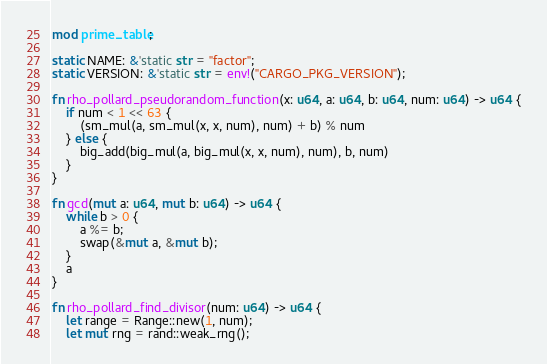<code> <loc_0><loc_0><loc_500><loc_500><_Rust_>mod prime_table;

static NAME: &'static str = "factor";
static VERSION: &'static str = env!("CARGO_PKG_VERSION");

fn rho_pollard_pseudorandom_function(x: u64, a: u64, b: u64, num: u64) -> u64 {
    if num < 1 << 63 {
        (sm_mul(a, sm_mul(x, x, num), num) + b) % num
    } else {
        big_add(big_mul(a, big_mul(x, x, num), num), b, num)
    }
}

fn gcd(mut a: u64, mut b: u64) -> u64 {
    while b > 0 {
        a %= b;
        swap(&mut a, &mut b);
    }
    a
}

fn rho_pollard_find_divisor(num: u64) -> u64 {
    let range = Range::new(1, num);
    let mut rng = rand::weak_rng();</code> 